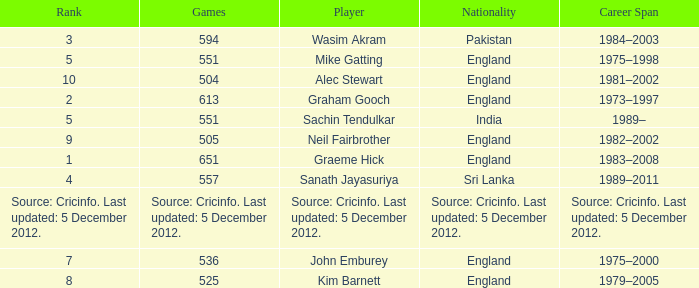What is the Nationality of Mike Gatting, who played 551 games? England. 